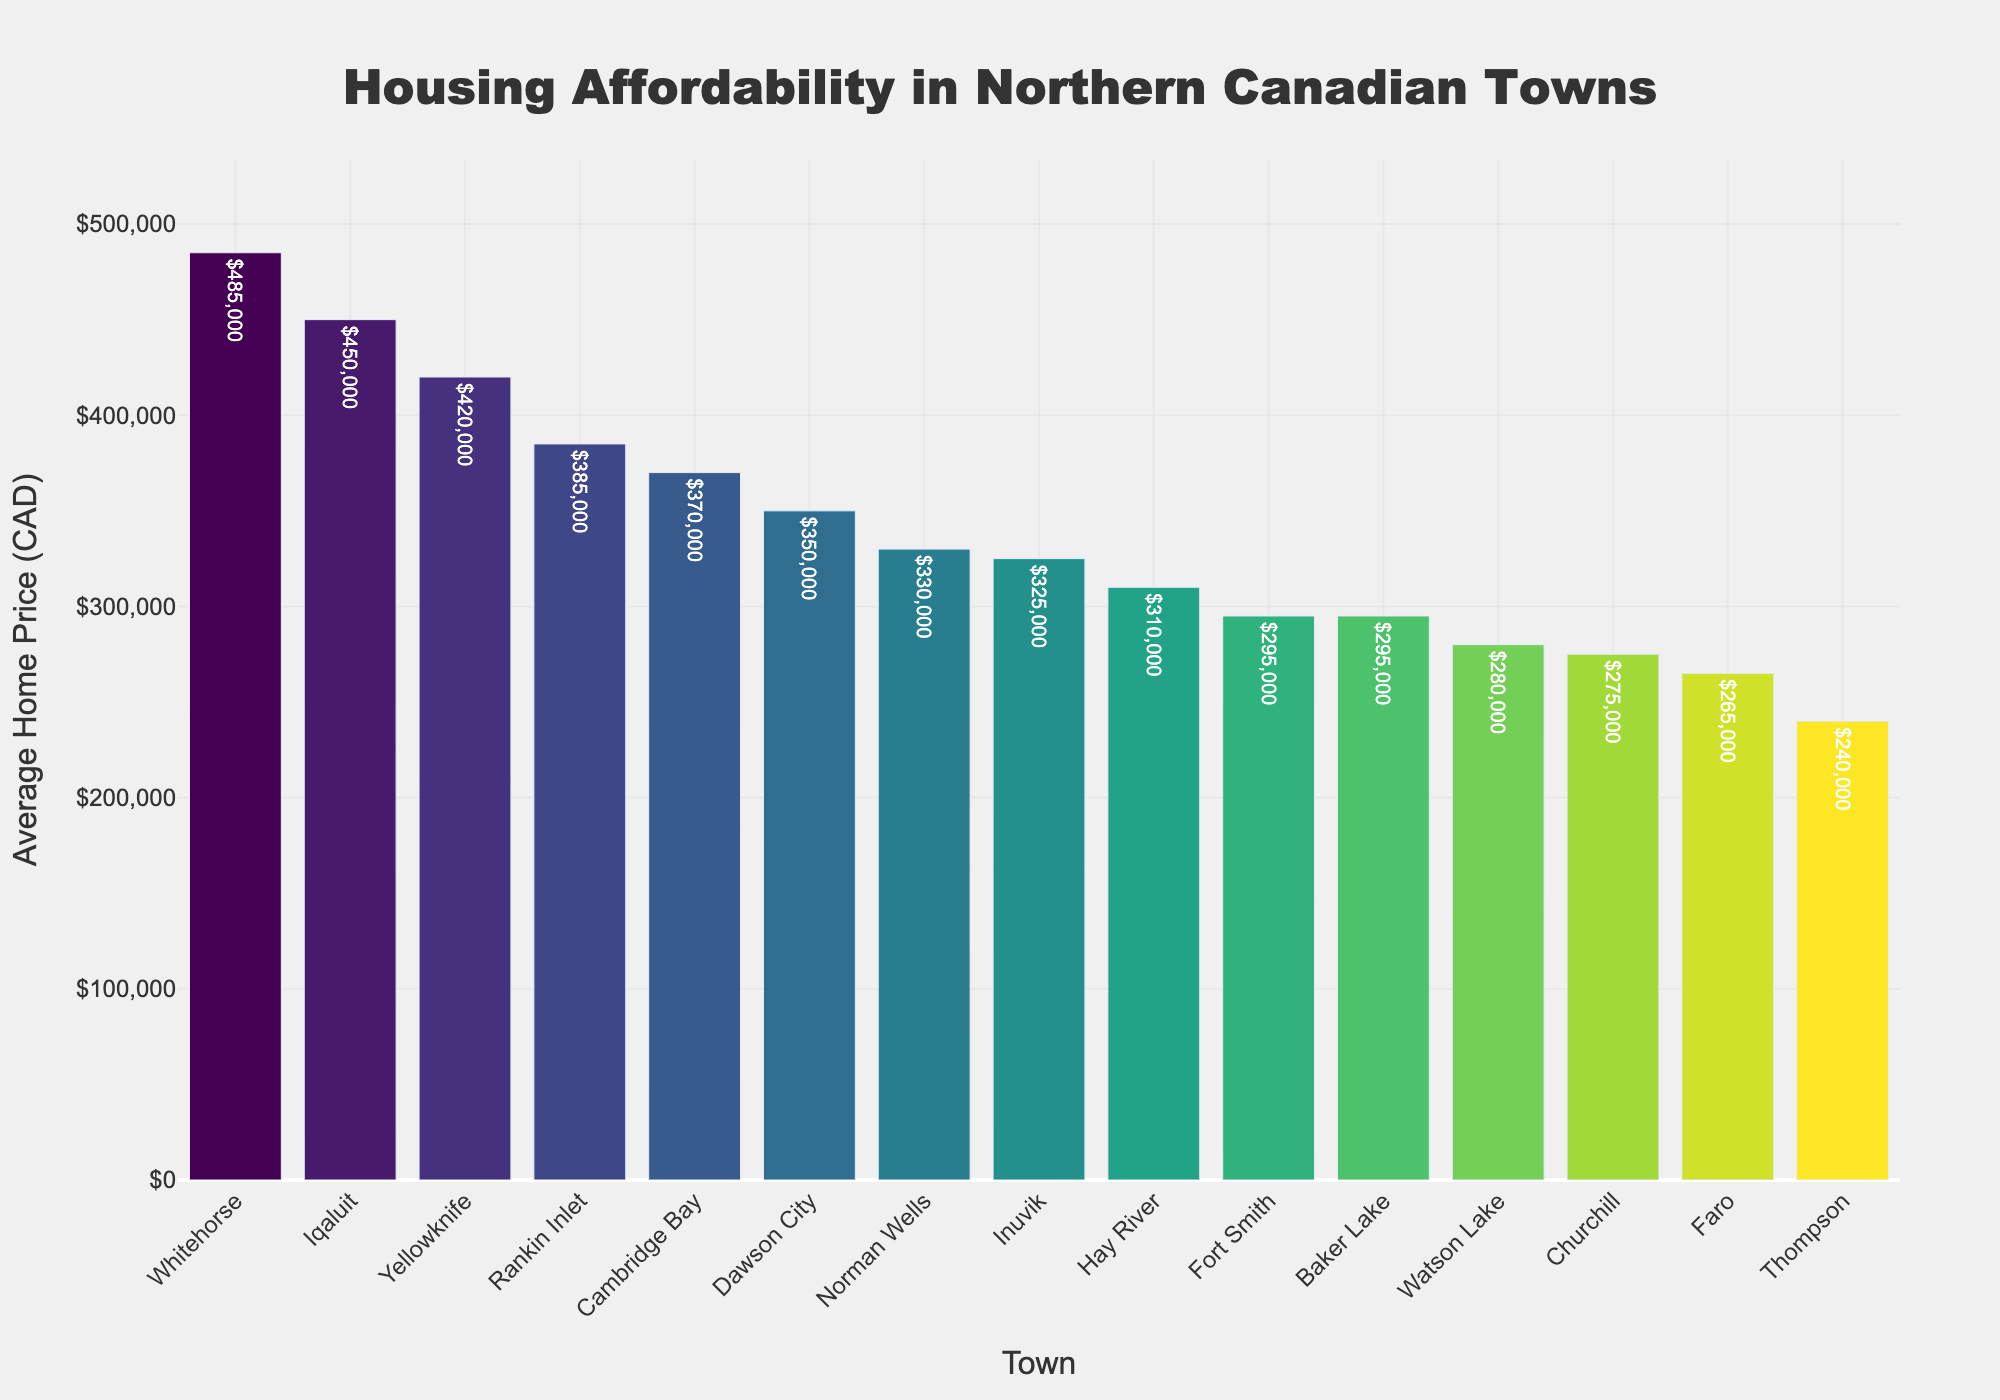Which town has the highest average home price? By examining the height of the bars, we can see that Whitehorse has the tallest bar, indicating the highest average home price.
Answer: Whitehorse Which town has the lowest average home price? By looking at the shortest bar in the chart, we see that Thompson has the lowest average home price.
Answer: Thompson What is the difference in average home price between Whitehorse and Thompson? Whitehorse has an average home price of $485,000, while Thompson has $240,000. The difference is $485,000 - $240,000.
Answer: $245,000 Which towns have average home prices greater than $400,000? By analyzing the bars above the $400,000 mark, we identify Whitehorse, Iqaluit, and Yellowknife.
Answer: Whitehorse, Iqaluit, Yellowknife What is the total average home price for the towns of Faro and Cambridge Bay? Faro has an average home price of $265,000, and Cambridge Bay has $370,000. Adding these values gives $265,000 + $370,000.
Answer: $635,000 How many towns have an average home price below $300,000? Counting the bars below the $300,000 mark, we find that there are six such towns: Thompson, Watson Lake, Churchill, Faro, Fort Smith, and Baker Lake.
Answer: 6 What is the median average home price of the towns? To find the median, the towns need to be ordered by average home price. The middle value in this ordered set is the median. For 15 towns, the 8th value in the sorted list is the median.
Answer: $325,000 Which town has a higher average home price: Dawson City or Norman Wells? By comparing the heights of the respective bars, we see that Norman Wells' bar is slightly higher than Dawson City's.
Answer: Norman Wells What is the combined average home price for towns starting with the letter "B"? The towns are Baker Lake with $295,000. Adding these values gives $295,000.
Answer: $295,000 What is the average home price difference between Churchill and Hay River? Churchill has an average home price of $275,000, and Hay River has $310,000. The difference is $310,000 - $275,000.
Answer: $35,000 